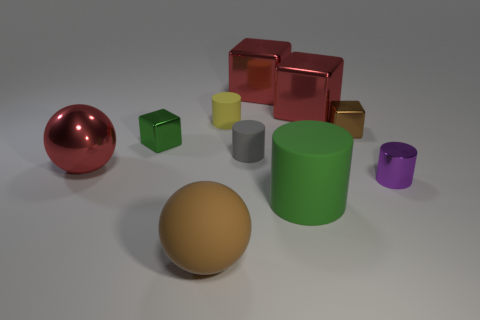How many other objects are the same color as the metal cylinder?
Provide a succinct answer. 0. What shape is the tiny rubber thing that is in front of the green object that is behind the red ball?
Provide a succinct answer. Cylinder. There is a green metallic thing; how many big cylinders are on the right side of it?
Your answer should be very brief. 1. Are there any tiny yellow objects made of the same material as the brown ball?
Give a very brief answer. Yes. There is a green cylinder that is the same size as the brown rubber sphere; what is its material?
Provide a short and direct response. Rubber. There is a matte object that is both behind the big rubber sphere and in front of the small purple cylinder; what size is it?
Keep it short and to the point. Large. The matte thing that is both in front of the small brown metallic block and behind the big green matte cylinder is what color?
Provide a succinct answer. Gray. Is the number of red metallic blocks on the right side of the big rubber cylinder less than the number of metallic objects behind the big matte sphere?
Provide a short and direct response. Yes. What number of large objects have the same shape as the tiny brown object?
Offer a terse response. 2. What size is the brown thing that is made of the same material as the tiny green cube?
Provide a short and direct response. Small. 